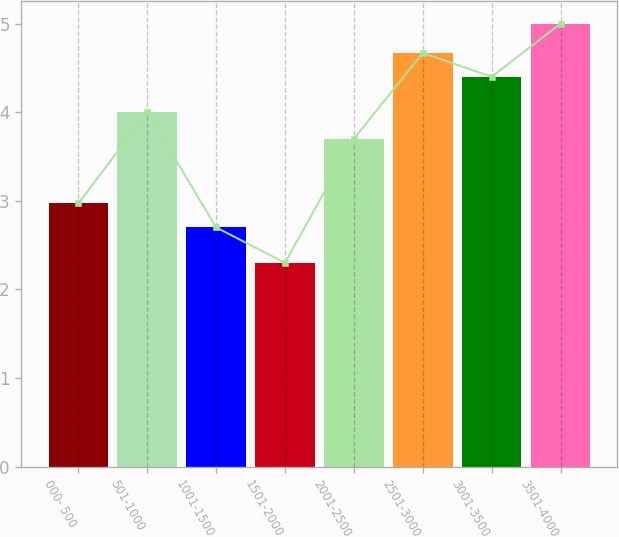<chart> <loc_0><loc_0><loc_500><loc_500><bar_chart><fcel>000- 500<fcel>501-1000<fcel>1001-1500<fcel>1501-2000<fcel>2001-2500<fcel>2501-3000<fcel>3001-3500<fcel>3501-4000<nl><fcel>2.97<fcel>4<fcel>2.7<fcel>2.3<fcel>3.7<fcel>4.67<fcel>4.4<fcel>5<nl></chart> 